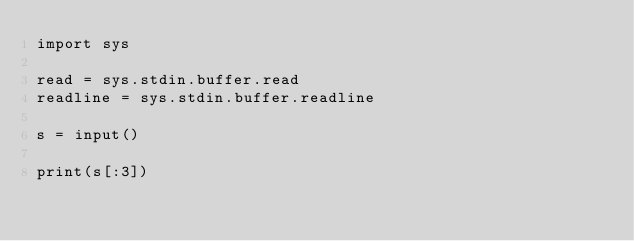Convert code to text. <code><loc_0><loc_0><loc_500><loc_500><_Python_>import sys

read = sys.stdin.buffer.read
readline = sys.stdin.buffer.readline

s = input()

print(s[:3])
</code> 